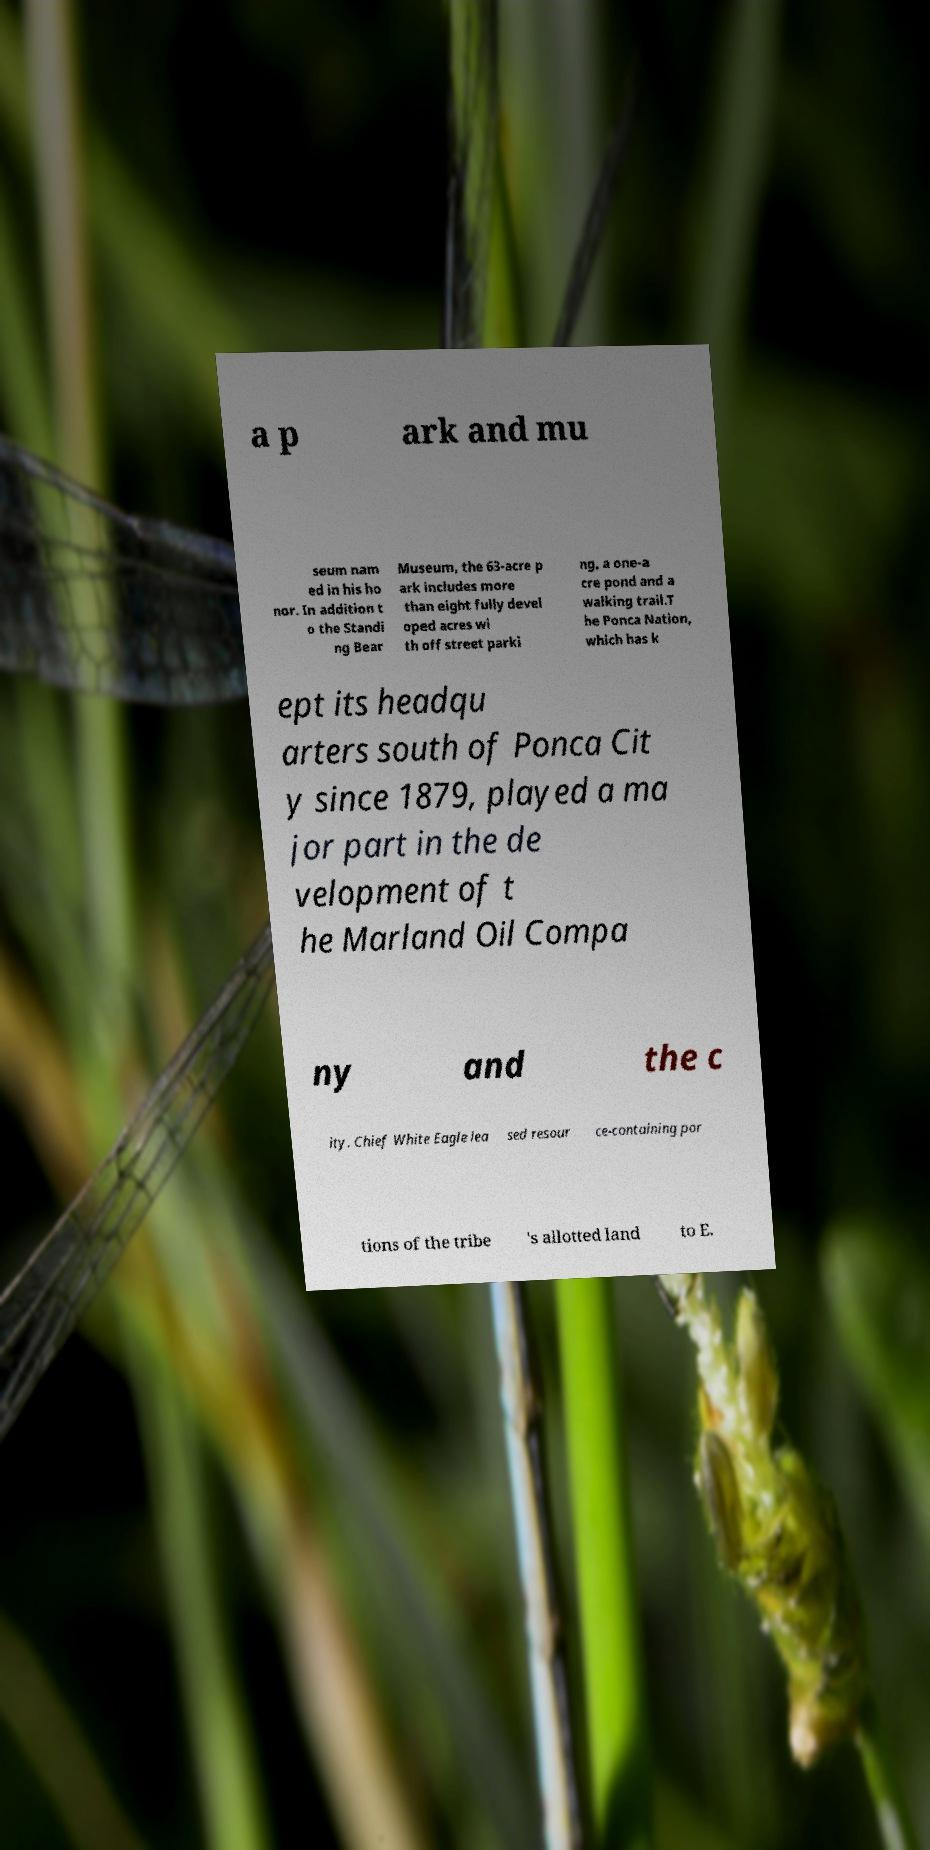Can you accurately transcribe the text from the provided image for me? a p ark and mu seum nam ed in his ho nor. In addition t o the Standi ng Bear Museum, the 63-acre p ark includes more than eight fully devel oped acres wi th off street parki ng, a one-a cre pond and a walking trail.T he Ponca Nation, which has k ept its headqu arters south of Ponca Cit y since 1879, played a ma jor part in the de velopment of t he Marland Oil Compa ny and the c ity. Chief White Eagle lea sed resour ce-containing por tions of the tribe 's allotted land to E. 